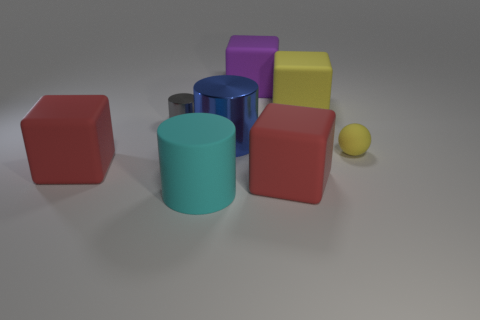There is a small object to the left of the large purple thing; does it have the same color as the cube left of the big purple block?
Keep it short and to the point. No. Is the number of large yellow things that are on the right side of the small cylinder greater than the number of gray shiny cylinders right of the large blue cylinder?
Keep it short and to the point. Yes. The other tiny shiny object that is the same shape as the blue metallic thing is what color?
Keep it short and to the point. Gray. Is there anything else that is the same shape as the large yellow object?
Ensure brevity in your answer.  Yes. There is a large yellow object; is it the same shape as the object on the left side of the gray cylinder?
Make the answer very short. Yes. How many other things are there of the same material as the yellow cube?
Make the answer very short. 5. What is the small object that is left of the tiny yellow object made of?
Offer a terse response. Metal. Is there a large rubber block that has the same color as the small matte object?
Your answer should be very brief. Yes. There is a shiny object that is the same size as the yellow matte cube; what is its color?
Keep it short and to the point. Blue. What number of tiny things are either metallic objects or yellow rubber balls?
Ensure brevity in your answer.  2. 